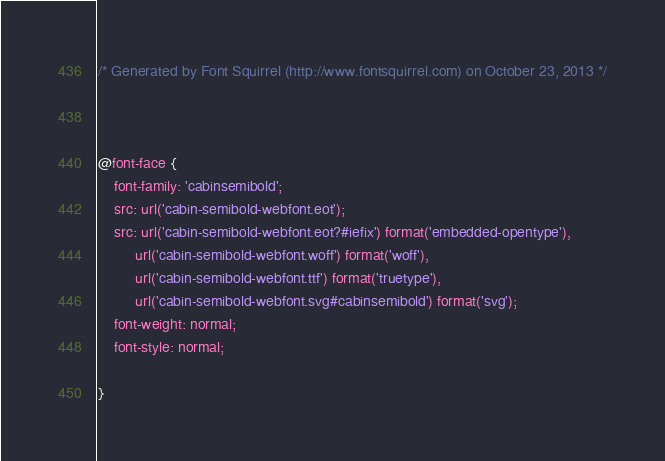Convert code to text. <code><loc_0><loc_0><loc_500><loc_500><_CSS_>/* Generated by Font Squirrel (http://www.fontsquirrel.com) on October 23, 2013 */



@font-face {
    font-family: 'cabinsemibold';
    src: url('cabin-semibold-webfont.eot');
    src: url('cabin-semibold-webfont.eot?#iefix') format('embedded-opentype'),
         url('cabin-semibold-webfont.woff') format('woff'),
         url('cabin-semibold-webfont.ttf') format('truetype'),
         url('cabin-semibold-webfont.svg#cabinsemibold') format('svg');
    font-weight: normal;
    font-style: normal;

}</code> 